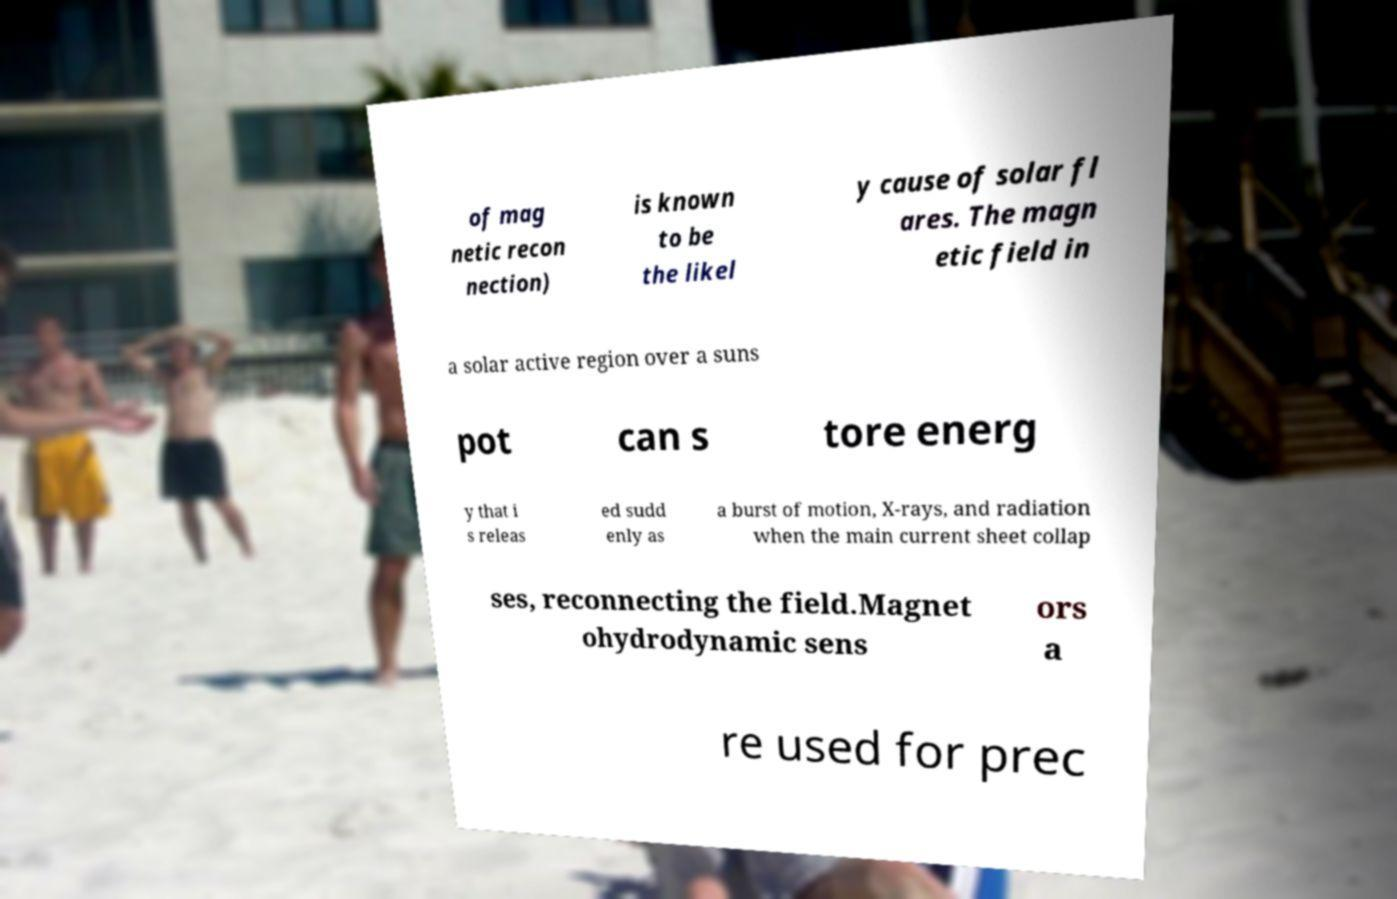Please identify and transcribe the text found in this image. of mag netic recon nection) is known to be the likel y cause of solar fl ares. The magn etic field in a solar active region over a suns pot can s tore energ y that i s releas ed sudd enly as a burst of motion, X-rays, and radiation when the main current sheet collap ses, reconnecting the field.Magnet ohydrodynamic sens ors a re used for prec 